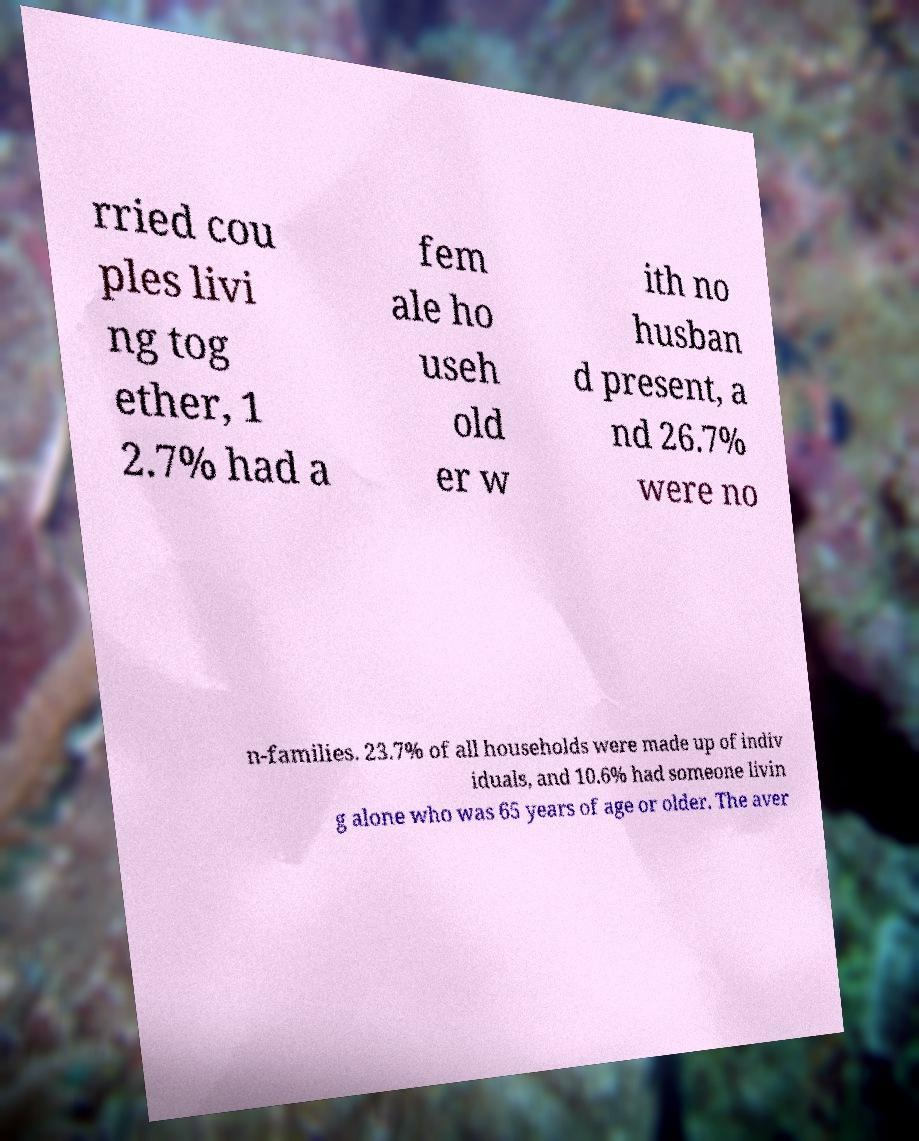For documentation purposes, I need the text within this image transcribed. Could you provide that? rried cou ples livi ng tog ether, 1 2.7% had a fem ale ho useh old er w ith no husban d present, a nd 26.7% were no n-families. 23.7% of all households were made up of indiv iduals, and 10.6% had someone livin g alone who was 65 years of age or older. The aver 